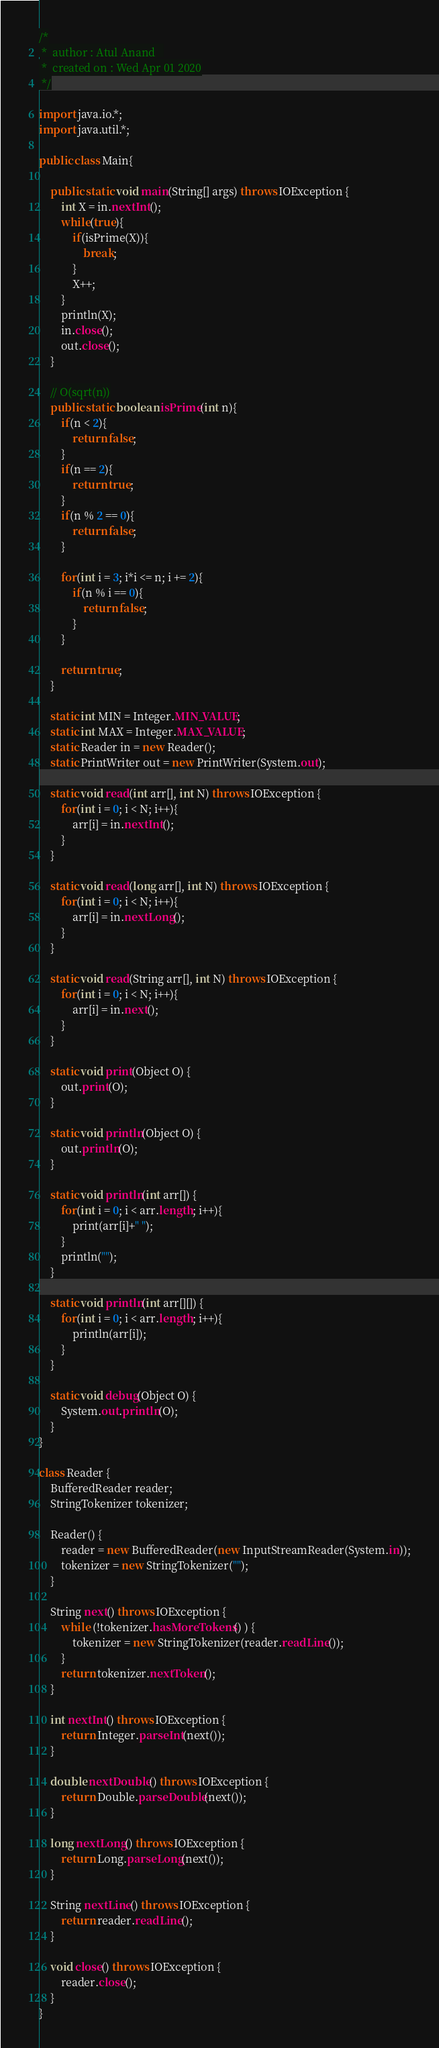Convert code to text. <code><loc_0><loc_0><loc_500><loc_500><_Java_>/*
 *  author : Atul Anand   
 *  created on : Wed Apr 01 2020
 */

import java.io.*;
import java.util.*;

public class Main{

    public static void main(String[] args) throws IOException {
        int X = in.nextInt();
        while(true){
            if(isPrime(X)){
                break;
            }
            X++;
        }
        println(X);
        in.close();
        out.close();
    }

    // O(sqrt(n))
    public static boolean isPrime(int n){
        if(n < 2){
            return false;
        }
        if(n == 2){
            return true;
        }
        if(n % 2 == 0){
            return false;
        }

        for(int i = 3; i*i <= n; i += 2){
            if(n % i == 0){
                return false;
            }
        }

        return true;
    }

    static int MIN = Integer.MIN_VALUE;
    static int MAX = Integer.MAX_VALUE;
    static Reader in = new Reader();
    static PrintWriter out = new PrintWriter(System.out);

    static void read(int arr[], int N) throws IOException { 
    	for(int i = 0; i < N; i++){ 
    		arr[i] = in.nextInt(); 
    	} 
    }
    
    static void read(long arr[], int N) throws IOException { 
    	for(int i = 0; i < N; i++){ 
    		arr[i] = in.nextLong(); 
    	} 
    }
    
    static void read(String arr[], int N) throws IOException { 
    	for(int i = 0; i < N; i++){ 
    		arr[i] = in.next(); 
    	} 
    }
    
    static void print(Object O) {  
    	out.print(O); 
    }
    
    static void println(Object O) { 
    	out.println(O); 
    }
    
    static void println(int arr[]) { 
    	for(int i = 0; i < arr.length; i++){ 
    		print(arr[i]+" "); 
    	} 
    	println(""); 
    }

    static void println(int arr[][]) { 
    	for(int i = 0; i < arr.length; i++){ 
    		println(arr[i]); 
    	}
    }
    
    static void debug(Object O) { 
    	System.out.println(O); 
    }
}

class Reader {
    BufferedReader reader;
    StringTokenizer tokenizer;

    Reader() {
        reader = new BufferedReader(new InputStreamReader(System.in));
        tokenizer = new StringTokenizer("");
    }

    String next() throws IOException {
        while (!tokenizer.hasMoreTokens() ) { 
            tokenizer = new StringTokenizer(reader.readLine()); 
        }
        return tokenizer.nextToken();
    }

    int nextInt() throws IOException { 
        return Integer.parseInt(next()); 
    }
    
    double nextDouble() throws IOException { 
        return Double.parseDouble(next());
    }
    
    long nextLong() throws IOException { 
        return Long.parseLong(next()); 
    }
    
    String nextLine() throws IOException { 
        return reader.readLine(); 
    }
    
    void close() throws IOException { 
        reader.close(); 
    }
}</code> 